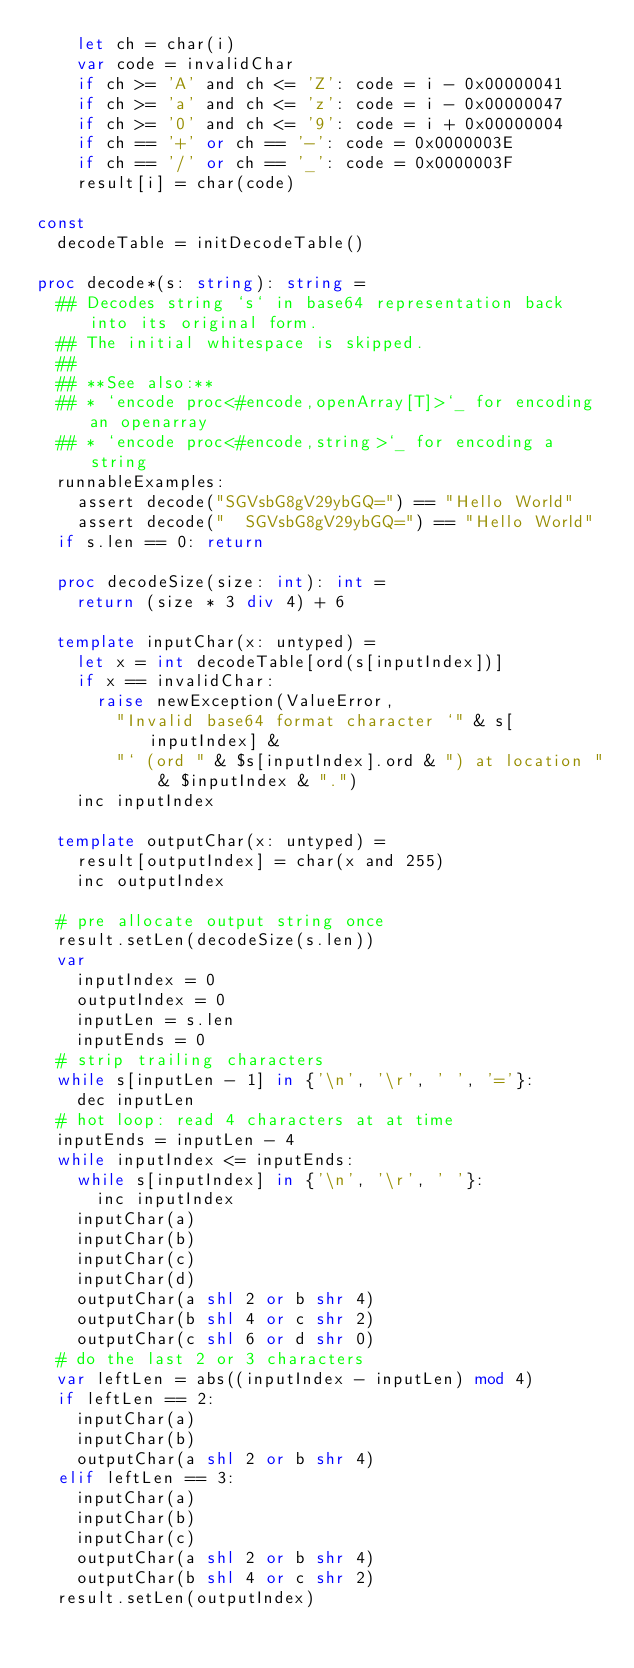<code> <loc_0><loc_0><loc_500><loc_500><_Nim_>    let ch = char(i)
    var code = invalidChar
    if ch >= 'A' and ch <= 'Z': code = i - 0x00000041
    if ch >= 'a' and ch <= 'z': code = i - 0x00000047
    if ch >= '0' and ch <= '9': code = i + 0x00000004
    if ch == '+' or ch == '-': code = 0x0000003E
    if ch == '/' or ch == '_': code = 0x0000003F
    result[i] = char(code)

const
  decodeTable = initDecodeTable()

proc decode*(s: string): string =
  ## Decodes string `s` in base64 representation back into its original form.
  ## The initial whitespace is skipped.
  ##
  ## **See also:**
  ## * `encode proc<#encode,openArray[T]>`_ for encoding an openarray
  ## * `encode proc<#encode,string>`_ for encoding a string
  runnableExamples:
    assert decode("SGVsbG8gV29ybGQ=") == "Hello World"
    assert decode("  SGVsbG8gV29ybGQ=") == "Hello World"
  if s.len == 0: return

  proc decodeSize(size: int): int =
    return (size * 3 div 4) + 6

  template inputChar(x: untyped) =
    let x = int decodeTable[ord(s[inputIndex])]
    if x == invalidChar:
      raise newException(ValueError,
        "Invalid base64 format character `" & s[inputIndex] &
        "` (ord " & $s[inputIndex].ord & ") at location " & $inputIndex & ".")
    inc inputIndex

  template outputChar(x: untyped) =
    result[outputIndex] = char(x and 255)
    inc outputIndex

  # pre allocate output string once
  result.setLen(decodeSize(s.len))
  var
    inputIndex = 0
    outputIndex = 0
    inputLen = s.len
    inputEnds = 0
  # strip trailing characters
  while s[inputLen - 1] in {'\n', '\r', ' ', '='}:
    dec inputLen
  # hot loop: read 4 characters at at time
  inputEnds = inputLen - 4
  while inputIndex <= inputEnds:
    while s[inputIndex] in {'\n', '\r', ' '}:
      inc inputIndex
    inputChar(a)
    inputChar(b)
    inputChar(c)
    inputChar(d)
    outputChar(a shl 2 or b shr 4)
    outputChar(b shl 4 or c shr 2)
    outputChar(c shl 6 or d shr 0)
  # do the last 2 or 3 characters
  var leftLen = abs((inputIndex - inputLen) mod 4)
  if leftLen == 2:
    inputChar(a)
    inputChar(b)
    outputChar(a shl 2 or b shr 4)
  elif leftLen == 3:
    inputChar(a)
    inputChar(b)
    inputChar(c)
    outputChar(a shl 2 or b shr 4)
    outputChar(b shl 4 or c shr 2)
  result.setLen(outputIndex)
</code> 